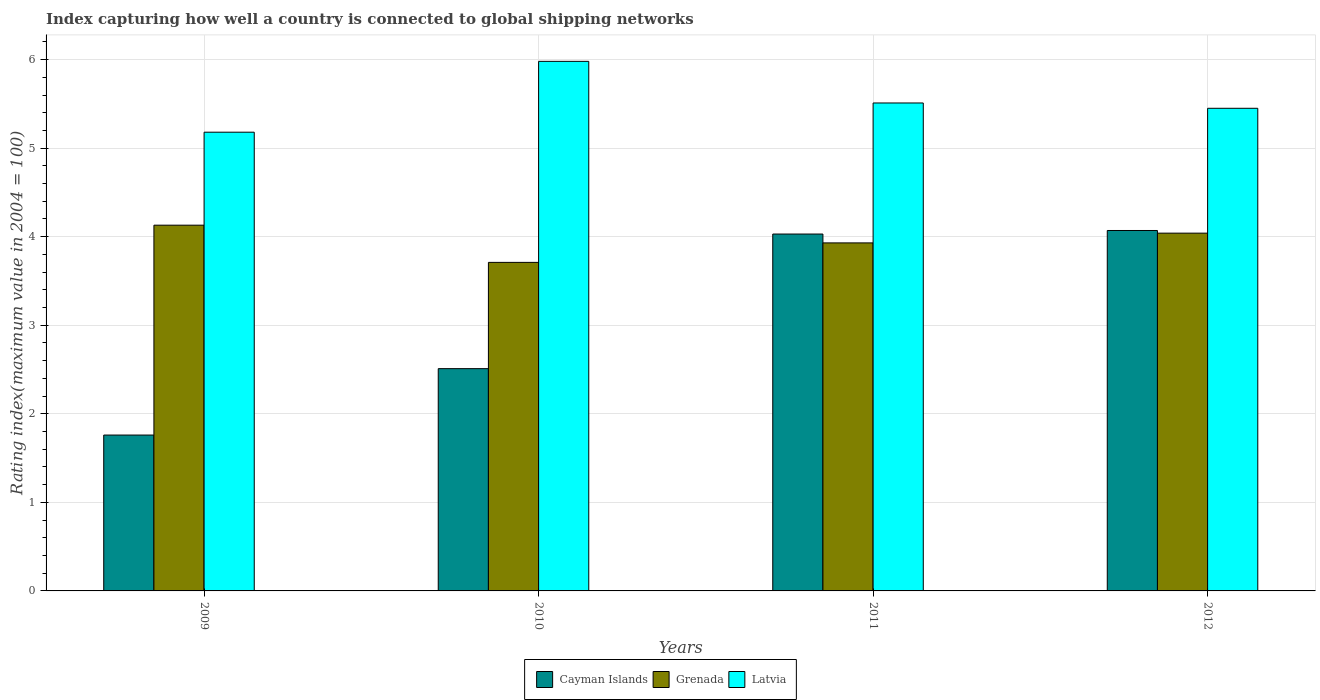How many different coloured bars are there?
Keep it short and to the point. 3. Are the number of bars per tick equal to the number of legend labels?
Ensure brevity in your answer.  Yes. How many bars are there on the 4th tick from the right?
Offer a terse response. 3. What is the label of the 2nd group of bars from the left?
Make the answer very short. 2010. What is the rating index in Cayman Islands in 2010?
Ensure brevity in your answer.  2.51. Across all years, what is the maximum rating index in Cayman Islands?
Offer a very short reply. 4.07. Across all years, what is the minimum rating index in Latvia?
Your answer should be compact. 5.18. In which year was the rating index in Cayman Islands maximum?
Your response must be concise. 2012. What is the total rating index in Cayman Islands in the graph?
Give a very brief answer. 12.37. What is the difference between the rating index in Latvia in 2010 and that in 2012?
Your answer should be compact. 0.53. What is the difference between the rating index in Grenada in 2010 and the rating index in Cayman Islands in 2009?
Keep it short and to the point. 1.95. What is the average rating index in Cayman Islands per year?
Offer a very short reply. 3.09. In the year 2009, what is the difference between the rating index in Latvia and rating index in Grenada?
Give a very brief answer. 1.05. In how many years, is the rating index in Latvia greater than 5?
Give a very brief answer. 4. What is the ratio of the rating index in Cayman Islands in 2011 to that in 2012?
Provide a short and direct response. 0.99. Is the rating index in Cayman Islands in 2010 less than that in 2012?
Ensure brevity in your answer.  Yes. What is the difference between the highest and the second highest rating index in Latvia?
Your answer should be compact. 0.47. What is the difference between the highest and the lowest rating index in Latvia?
Offer a very short reply. 0.8. Is the sum of the rating index in Cayman Islands in 2010 and 2011 greater than the maximum rating index in Latvia across all years?
Make the answer very short. Yes. What does the 3rd bar from the left in 2010 represents?
Offer a terse response. Latvia. What does the 2nd bar from the right in 2012 represents?
Make the answer very short. Grenada. Is it the case that in every year, the sum of the rating index in Latvia and rating index in Grenada is greater than the rating index in Cayman Islands?
Provide a succinct answer. Yes. What is the difference between two consecutive major ticks on the Y-axis?
Offer a very short reply. 1. Are the values on the major ticks of Y-axis written in scientific E-notation?
Offer a terse response. No. Does the graph contain grids?
Your response must be concise. Yes. Where does the legend appear in the graph?
Ensure brevity in your answer.  Bottom center. How many legend labels are there?
Ensure brevity in your answer.  3. What is the title of the graph?
Your answer should be compact. Index capturing how well a country is connected to global shipping networks. Does "Japan" appear as one of the legend labels in the graph?
Your answer should be very brief. No. What is the label or title of the X-axis?
Your answer should be very brief. Years. What is the label or title of the Y-axis?
Offer a very short reply. Rating index(maximum value in 2004 = 100). What is the Rating index(maximum value in 2004 = 100) in Cayman Islands in 2009?
Your response must be concise. 1.76. What is the Rating index(maximum value in 2004 = 100) of Grenada in 2009?
Offer a terse response. 4.13. What is the Rating index(maximum value in 2004 = 100) in Latvia in 2009?
Provide a succinct answer. 5.18. What is the Rating index(maximum value in 2004 = 100) in Cayman Islands in 2010?
Offer a terse response. 2.51. What is the Rating index(maximum value in 2004 = 100) in Grenada in 2010?
Give a very brief answer. 3.71. What is the Rating index(maximum value in 2004 = 100) of Latvia in 2010?
Offer a terse response. 5.98. What is the Rating index(maximum value in 2004 = 100) of Cayman Islands in 2011?
Make the answer very short. 4.03. What is the Rating index(maximum value in 2004 = 100) of Grenada in 2011?
Your answer should be compact. 3.93. What is the Rating index(maximum value in 2004 = 100) in Latvia in 2011?
Keep it short and to the point. 5.51. What is the Rating index(maximum value in 2004 = 100) in Cayman Islands in 2012?
Provide a short and direct response. 4.07. What is the Rating index(maximum value in 2004 = 100) in Grenada in 2012?
Give a very brief answer. 4.04. What is the Rating index(maximum value in 2004 = 100) in Latvia in 2012?
Your answer should be compact. 5.45. Across all years, what is the maximum Rating index(maximum value in 2004 = 100) of Cayman Islands?
Provide a succinct answer. 4.07. Across all years, what is the maximum Rating index(maximum value in 2004 = 100) of Grenada?
Your answer should be compact. 4.13. Across all years, what is the maximum Rating index(maximum value in 2004 = 100) in Latvia?
Provide a short and direct response. 5.98. Across all years, what is the minimum Rating index(maximum value in 2004 = 100) in Cayman Islands?
Your answer should be compact. 1.76. Across all years, what is the minimum Rating index(maximum value in 2004 = 100) of Grenada?
Make the answer very short. 3.71. Across all years, what is the minimum Rating index(maximum value in 2004 = 100) of Latvia?
Your answer should be very brief. 5.18. What is the total Rating index(maximum value in 2004 = 100) of Cayman Islands in the graph?
Your answer should be compact. 12.37. What is the total Rating index(maximum value in 2004 = 100) in Grenada in the graph?
Keep it short and to the point. 15.81. What is the total Rating index(maximum value in 2004 = 100) in Latvia in the graph?
Provide a short and direct response. 22.12. What is the difference between the Rating index(maximum value in 2004 = 100) of Cayman Islands in 2009 and that in 2010?
Give a very brief answer. -0.75. What is the difference between the Rating index(maximum value in 2004 = 100) in Grenada in 2009 and that in 2010?
Your answer should be very brief. 0.42. What is the difference between the Rating index(maximum value in 2004 = 100) in Latvia in 2009 and that in 2010?
Offer a very short reply. -0.8. What is the difference between the Rating index(maximum value in 2004 = 100) in Cayman Islands in 2009 and that in 2011?
Give a very brief answer. -2.27. What is the difference between the Rating index(maximum value in 2004 = 100) in Grenada in 2009 and that in 2011?
Your response must be concise. 0.2. What is the difference between the Rating index(maximum value in 2004 = 100) in Latvia in 2009 and that in 2011?
Make the answer very short. -0.33. What is the difference between the Rating index(maximum value in 2004 = 100) in Cayman Islands in 2009 and that in 2012?
Your answer should be very brief. -2.31. What is the difference between the Rating index(maximum value in 2004 = 100) of Grenada in 2009 and that in 2012?
Make the answer very short. 0.09. What is the difference between the Rating index(maximum value in 2004 = 100) in Latvia in 2009 and that in 2012?
Keep it short and to the point. -0.27. What is the difference between the Rating index(maximum value in 2004 = 100) in Cayman Islands in 2010 and that in 2011?
Keep it short and to the point. -1.52. What is the difference between the Rating index(maximum value in 2004 = 100) of Grenada in 2010 and that in 2011?
Ensure brevity in your answer.  -0.22. What is the difference between the Rating index(maximum value in 2004 = 100) of Latvia in 2010 and that in 2011?
Your answer should be very brief. 0.47. What is the difference between the Rating index(maximum value in 2004 = 100) of Cayman Islands in 2010 and that in 2012?
Offer a terse response. -1.56. What is the difference between the Rating index(maximum value in 2004 = 100) in Grenada in 2010 and that in 2012?
Give a very brief answer. -0.33. What is the difference between the Rating index(maximum value in 2004 = 100) in Latvia in 2010 and that in 2012?
Offer a terse response. 0.53. What is the difference between the Rating index(maximum value in 2004 = 100) of Cayman Islands in 2011 and that in 2012?
Offer a very short reply. -0.04. What is the difference between the Rating index(maximum value in 2004 = 100) in Grenada in 2011 and that in 2012?
Make the answer very short. -0.11. What is the difference between the Rating index(maximum value in 2004 = 100) in Latvia in 2011 and that in 2012?
Give a very brief answer. 0.06. What is the difference between the Rating index(maximum value in 2004 = 100) of Cayman Islands in 2009 and the Rating index(maximum value in 2004 = 100) of Grenada in 2010?
Make the answer very short. -1.95. What is the difference between the Rating index(maximum value in 2004 = 100) of Cayman Islands in 2009 and the Rating index(maximum value in 2004 = 100) of Latvia in 2010?
Provide a succinct answer. -4.22. What is the difference between the Rating index(maximum value in 2004 = 100) in Grenada in 2009 and the Rating index(maximum value in 2004 = 100) in Latvia in 2010?
Your answer should be compact. -1.85. What is the difference between the Rating index(maximum value in 2004 = 100) in Cayman Islands in 2009 and the Rating index(maximum value in 2004 = 100) in Grenada in 2011?
Provide a short and direct response. -2.17. What is the difference between the Rating index(maximum value in 2004 = 100) in Cayman Islands in 2009 and the Rating index(maximum value in 2004 = 100) in Latvia in 2011?
Your answer should be compact. -3.75. What is the difference between the Rating index(maximum value in 2004 = 100) in Grenada in 2009 and the Rating index(maximum value in 2004 = 100) in Latvia in 2011?
Offer a very short reply. -1.38. What is the difference between the Rating index(maximum value in 2004 = 100) in Cayman Islands in 2009 and the Rating index(maximum value in 2004 = 100) in Grenada in 2012?
Make the answer very short. -2.28. What is the difference between the Rating index(maximum value in 2004 = 100) in Cayman Islands in 2009 and the Rating index(maximum value in 2004 = 100) in Latvia in 2012?
Provide a short and direct response. -3.69. What is the difference between the Rating index(maximum value in 2004 = 100) in Grenada in 2009 and the Rating index(maximum value in 2004 = 100) in Latvia in 2012?
Provide a short and direct response. -1.32. What is the difference between the Rating index(maximum value in 2004 = 100) in Cayman Islands in 2010 and the Rating index(maximum value in 2004 = 100) in Grenada in 2011?
Provide a succinct answer. -1.42. What is the difference between the Rating index(maximum value in 2004 = 100) in Grenada in 2010 and the Rating index(maximum value in 2004 = 100) in Latvia in 2011?
Ensure brevity in your answer.  -1.8. What is the difference between the Rating index(maximum value in 2004 = 100) in Cayman Islands in 2010 and the Rating index(maximum value in 2004 = 100) in Grenada in 2012?
Your answer should be compact. -1.53. What is the difference between the Rating index(maximum value in 2004 = 100) of Cayman Islands in 2010 and the Rating index(maximum value in 2004 = 100) of Latvia in 2012?
Make the answer very short. -2.94. What is the difference between the Rating index(maximum value in 2004 = 100) in Grenada in 2010 and the Rating index(maximum value in 2004 = 100) in Latvia in 2012?
Offer a very short reply. -1.74. What is the difference between the Rating index(maximum value in 2004 = 100) in Cayman Islands in 2011 and the Rating index(maximum value in 2004 = 100) in Grenada in 2012?
Provide a succinct answer. -0.01. What is the difference between the Rating index(maximum value in 2004 = 100) of Cayman Islands in 2011 and the Rating index(maximum value in 2004 = 100) of Latvia in 2012?
Offer a terse response. -1.42. What is the difference between the Rating index(maximum value in 2004 = 100) in Grenada in 2011 and the Rating index(maximum value in 2004 = 100) in Latvia in 2012?
Provide a short and direct response. -1.52. What is the average Rating index(maximum value in 2004 = 100) in Cayman Islands per year?
Make the answer very short. 3.09. What is the average Rating index(maximum value in 2004 = 100) of Grenada per year?
Ensure brevity in your answer.  3.95. What is the average Rating index(maximum value in 2004 = 100) of Latvia per year?
Give a very brief answer. 5.53. In the year 2009, what is the difference between the Rating index(maximum value in 2004 = 100) in Cayman Islands and Rating index(maximum value in 2004 = 100) in Grenada?
Give a very brief answer. -2.37. In the year 2009, what is the difference between the Rating index(maximum value in 2004 = 100) in Cayman Islands and Rating index(maximum value in 2004 = 100) in Latvia?
Your answer should be compact. -3.42. In the year 2009, what is the difference between the Rating index(maximum value in 2004 = 100) of Grenada and Rating index(maximum value in 2004 = 100) of Latvia?
Ensure brevity in your answer.  -1.05. In the year 2010, what is the difference between the Rating index(maximum value in 2004 = 100) in Cayman Islands and Rating index(maximum value in 2004 = 100) in Latvia?
Offer a very short reply. -3.47. In the year 2010, what is the difference between the Rating index(maximum value in 2004 = 100) of Grenada and Rating index(maximum value in 2004 = 100) of Latvia?
Offer a very short reply. -2.27. In the year 2011, what is the difference between the Rating index(maximum value in 2004 = 100) of Cayman Islands and Rating index(maximum value in 2004 = 100) of Latvia?
Ensure brevity in your answer.  -1.48. In the year 2011, what is the difference between the Rating index(maximum value in 2004 = 100) of Grenada and Rating index(maximum value in 2004 = 100) of Latvia?
Offer a very short reply. -1.58. In the year 2012, what is the difference between the Rating index(maximum value in 2004 = 100) in Cayman Islands and Rating index(maximum value in 2004 = 100) in Latvia?
Provide a short and direct response. -1.38. In the year 2012, what is the difference between the Rating index(maximum value in 2004 = 100) in Grenada and Rating index(maximum value in 2004 = 100) in Latvia?
Your response must be concise. -1.41. What is the ratio of the Rating index(maximum value in 2004 = 100) in Cayman Islands in 2009 to that in 2010?
Provide a short and direct response. 0.7. What is the ratio of the Rating index(maximum value in 2004 = 100) of Grenada in 2009 to that in 2010?
Your answer should be very brief. 1.11. What is the ratio of the Rating index(maximum value in 2004 = 100) of Latvia in 2009 to that in 2010?
Ensure brevity in your answer.  0.87. What is the ratio of the Rating index(maximum value in 2004 = 100) of Cayman Islands in 2009 to that in 2011?
Your answer should be very brief. 0.44. What is the ratio of the Rating index(maximum value in 2004 = 100) in Grenada in 2009 to that in 2011?
Provide a succinct answer. 1.05. What is the ratio of the Rating index(maximum value in 2004 = 100) of Latvia in 2009 to that in 2011?
Your answer should be compact. 0.94. What is the ratio of the Rating index(maximum value in 2004 = 100) in Cayman Islands in 2009 to that in 2012?
Your answer should be compact. 0.43. What is the ratio of the Rating index(maximum value in 2004 = 100) in Grenada in 2009 to that in 2012?
Make the answer very short. 1.02. What is the ratio of the Rating index(maximum value in 2004 = 100) in Latvia in 2009 to that in 2012?
Your answer should be very brief. 0.95. What is the ratio of the Rating index(maximum value in 2004 = 100) of Cayman Islands in 2010 to that in 2011?
Provide a short and direct response. 0.62. What is the ratio of the Rating index(maximum value in 2004 = 100) in Grenada in 2010 to that in 2011?
Ensure brevity in your answer.  0.94. What is the ratio of the Rating index(maximum value in 2004 = 100) of Latvia in 2010 to that in 2011?
Give a very brief answer. 1.09. What is the ratio of the Rating index(maximum value in 2004 = 100) in Cayman Islands in 2010 to that in 2012?
Your answer should be very brief. 0.62. What is the ratio of the Rating index(maximum value in 2004 = 100) in Grenada in 2010 to that in 2012?
Make the answer very short. 0.92. What is the ratio of the Rating index(maximum value in 2004 = 100) in Latvia in 2010 to that in 2012?
Your answer should be compact. 1.1. What is the ratio of the Rating index(maximum value in 2004 = 100) of Cayman Islands in 2011 to that in 2012?
Provide a short and direct response. 0.99. What is the ratio of the Rating index(maximum value in 2004 = 100) in Grenada in 2011 to that in 2012?
Provide a short and direct response. 0.97. What is the ratio of the Rating index(maximum value in 2004 = 100) in Latvia in 2011 to that in 2012?
Provide a short and direct response. 1.01. What is the difference between the highest and the second highest Rating index(maximum value in 2004 = 100) in Grenada?
Offer a very short reply. 0.09. What is the difference between the highest and the second highest Rating index(maximum value in 2004 = 100) of Latvia?
Your answer should be very brief. 0.47. What is the difference between the highest and the lowest Rating index(maximum value in 2004 = 100) of Cayman Islands?
Your response must be concise. 2.31. What is the difference between the highest and the lowest Rating index(maximum value in 2004 = 100) of Grenada?
Provide a succinct answer. 0.42. What is the difference between the highest and the lowest Rating index(maximum value in 2004 = 100) of Latvia?
Your response must be concise. 0.8. 